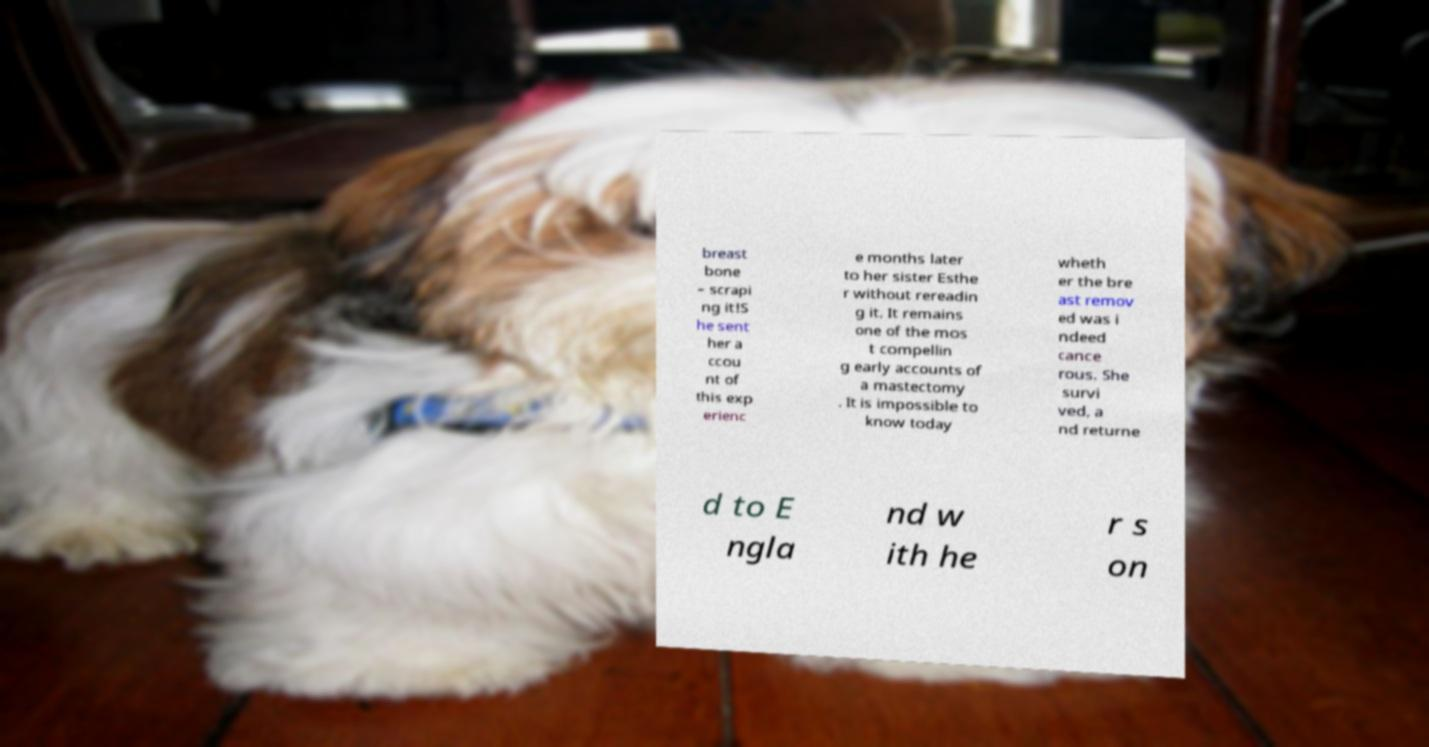Could you assist in decoding the text presented in this image and type it out clearly? breast bone – scrapi ng it!S he sent her a ccou nt of this exp erienc e months later to her sister Esthe r without rereadin g it. It remains one of the mos t compellin g early accounts of a mastectomy . It is impossible to know today wheth er the bre ast remov ed was i ndeed cance rous. She survi ved, a nd returne d to E ngla nd w ith he r s on 